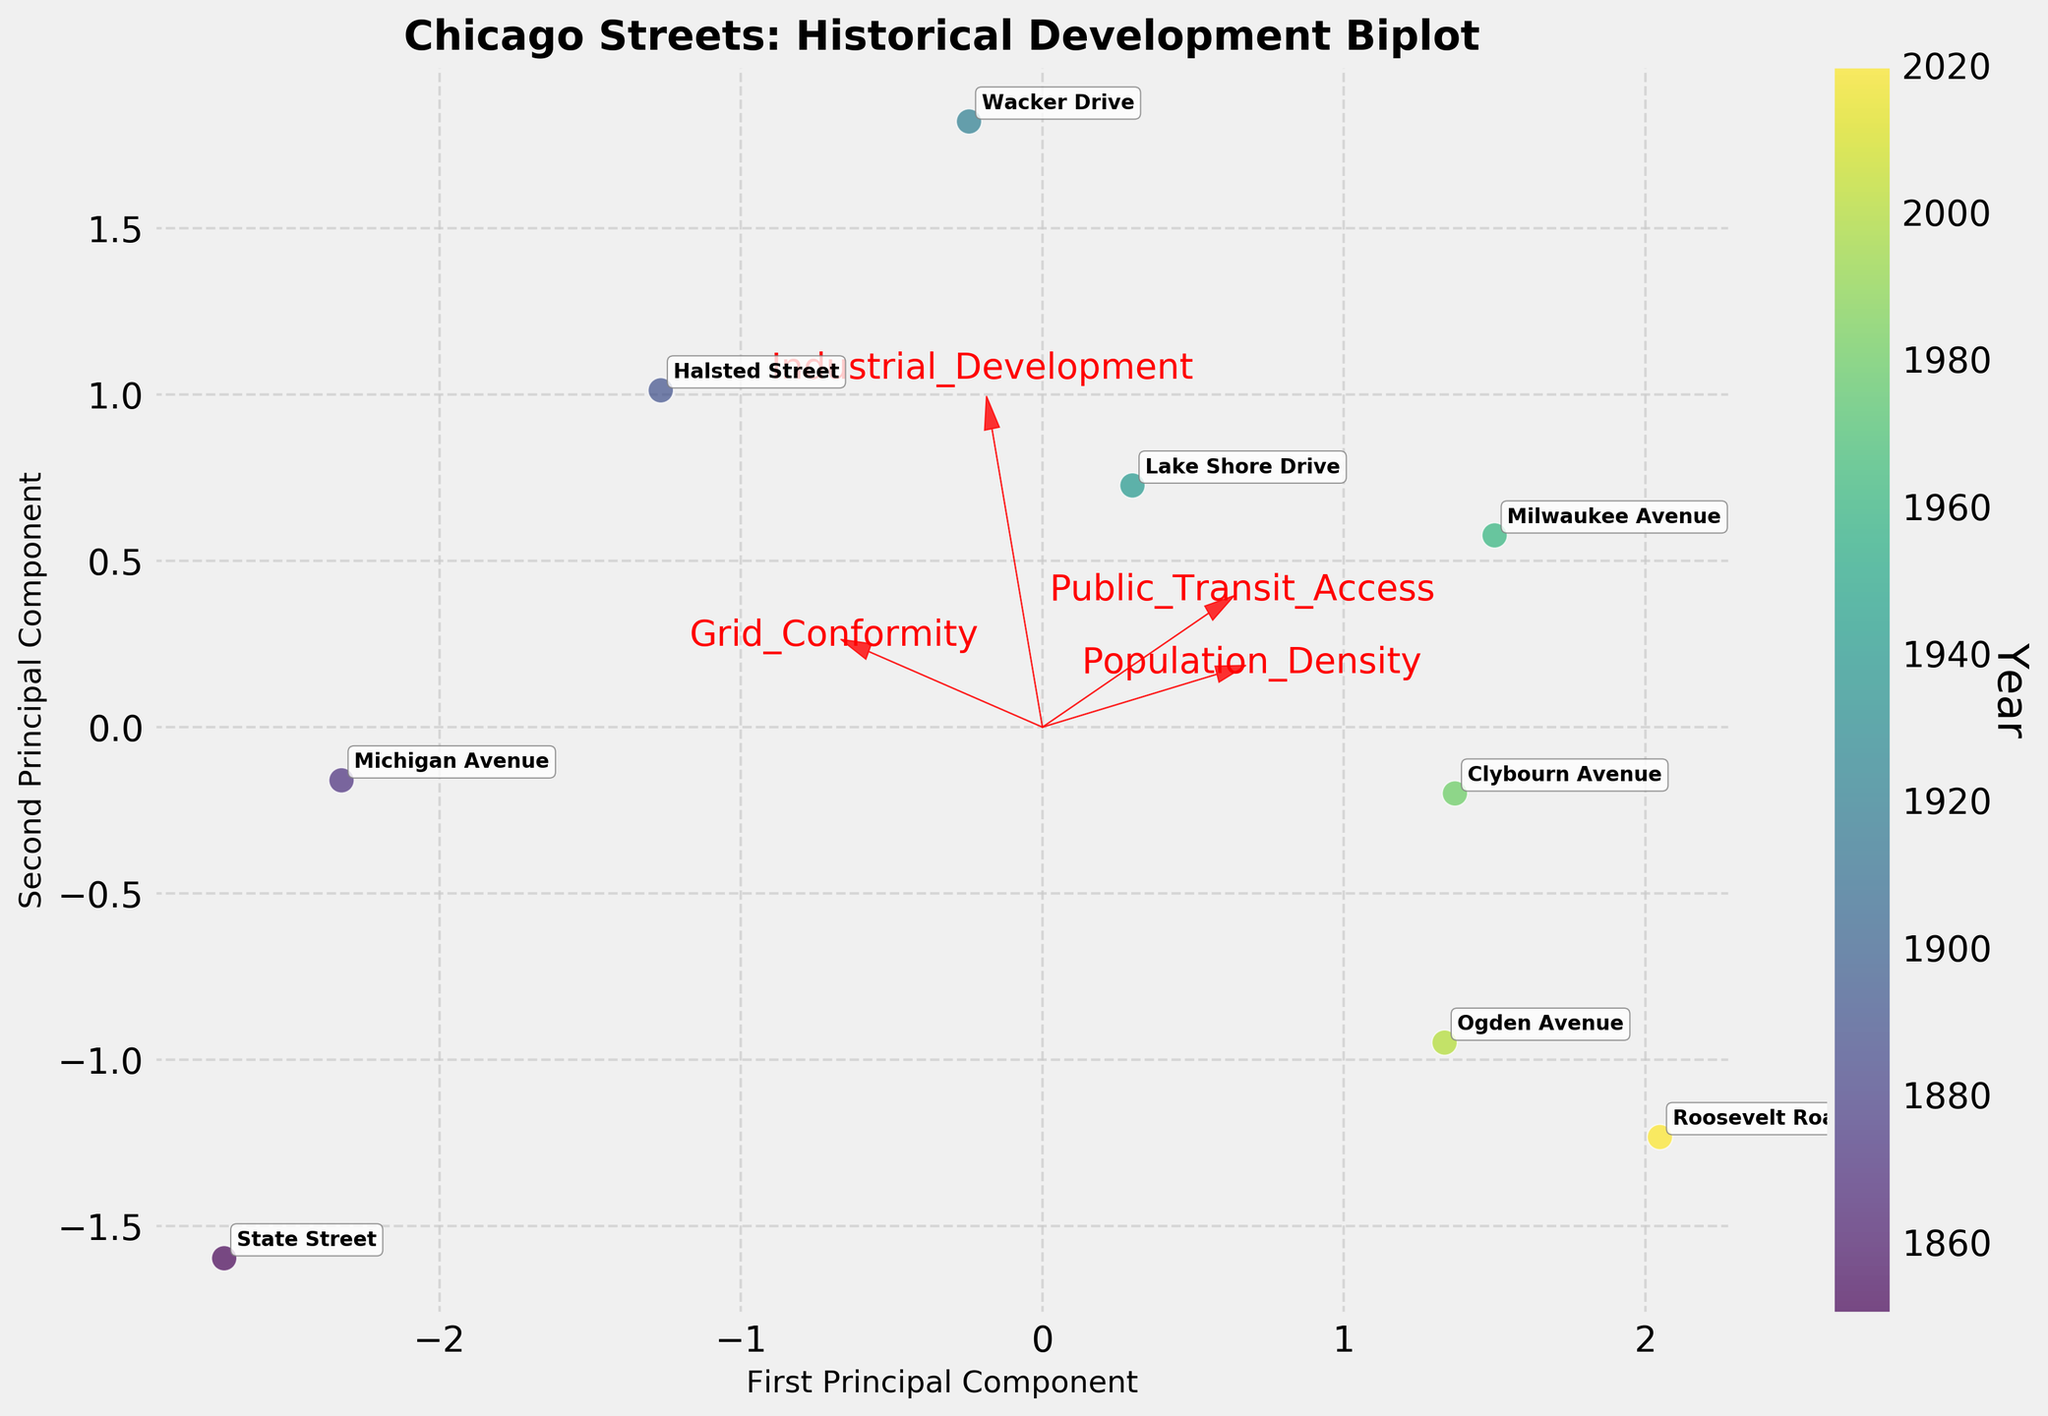What is the title of the figure? The title of the figure is usually positioned at the top of the plot. Reading from this area, we find the title "Chicago Streets: Historical Development Biplot".
Answer: Chicago Streets: Historical Development Biplot What is the color scheme used to represent the years? The color scheme used to represent the years ranges from lighter to darker shades of a single color. Observing the color bar, we see it's a gradient from lighter to darker shades of green, indicating that the color corresponds to the year a street was developed.
Answer: Green gradient Which street appears furthest along the first principal component axis? Observing the scatter plot, the street that is furthest along the first principal component axis (the x-axis) is "Roosevelt Road", as its point is located farthest to the right on this axis.
Answer: Roosevelt Road Where is the vector for "Population Density" in relation to the origin? Observing the vectors that originate from the center or origin of the plot, the vector for "Population Density" points approximately to the right, indicating a positive correlation with the first principal component.
Answer: To the right Which street had the highest level of Public Transit Access in 2020? This requires examining the points and the corresponding street labels from the year 2020. From the annotation near "Roosevelt Road", we see the street and year match up and review the position of Public Transit Access vector. "Roosevelt Road" is closely aligned with the Public Transit Access vector.
Answer: Roosevelt Road How do "Clybourn Avenue" and "Michigan Avenue" compare in terms of Industrial Development? Look at the relative positions of Clybourn Avenue and Michigan Avenue in the plot and their proximities to the Industrial Development vector. Clybourn Avenue is further from the Industrial Development vector compared to Michigan Avenue, indicating lower Industrial Development.
Answer: Clybourn Avenue has lower Industrial Development than Michigan Avenue Which feature has the least impact on the second principal component? By examining the lengths of the vectors from the origin, the shortest vector relative to the second principal component axis (the y-axis) indicates "Grid Conformity".
Answer: Grid Conformity Estimate the relationship between Grid Conformity and Population Density from 1850 to 2020. To estimate this, observe the relative positions of the "Grid Conformity" and "Population Density" vectors. These vectors aren't aligned closely, suggesting a weak or negative relationship over the given years. Additionally, seeing the data points spread out relative to the two vectors further supports this observation.
Answer: Weak or negative relationship 